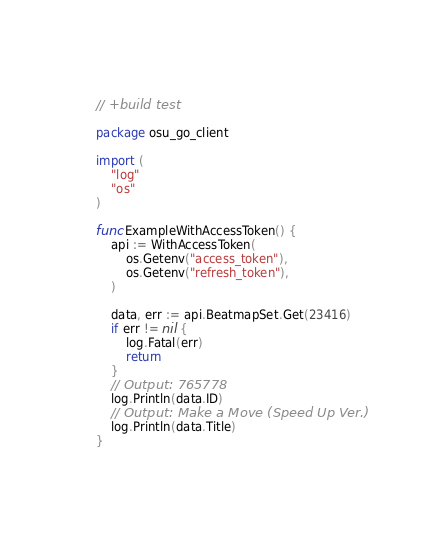<code> <loc_0><loc_0><loc_500><loc_500><_Go_>// +build test

package osu_go_client

import (
	"log"
	"os"
)

func ExampleWithAccessToken() {
	api := WithAccessToken(
		os.Getenv("access_token"),
		os.Getenv("refresh_token"),
	)

	data, err := api.BeatmapSet.Get(23416)
	if err != nil {
		log.Fatal(err)
		return
	}
	// Output: 765778
	log.Println(data.ID)
	// Output: Make a Move (Speed Up Ver.)
	log.Println(data.Title)
}
</code> 